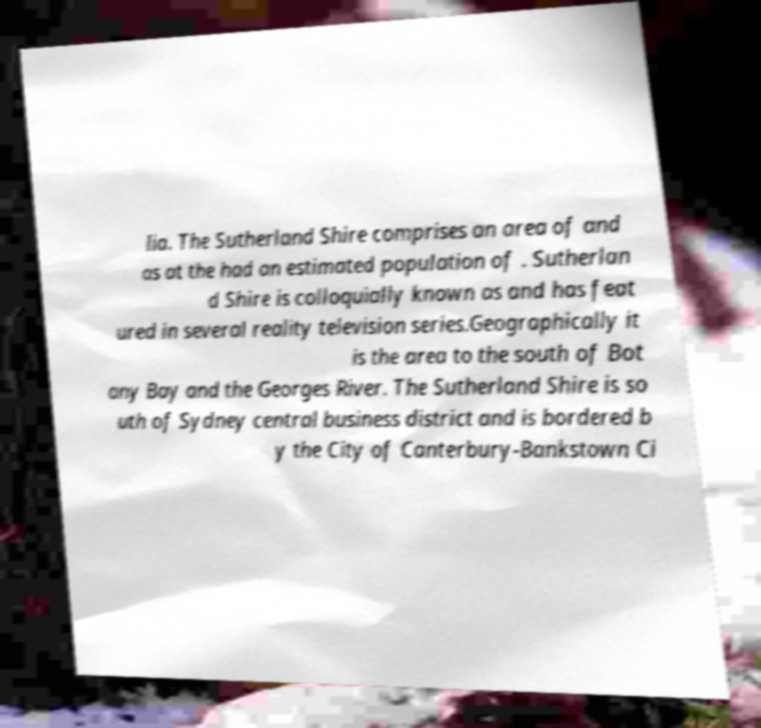There's text embedded in this image that I need extracted. Can you transcribe it verbatim? lia. The Sutherland Shire comprises an area of and as at the had an estimated population of . Sutherlan d Shire is colloquially known as and has feat ured in several reality television series.Geographically it is the area to the south of Bot any Bay and the Georges River. The Sutherland Shire is so uth of Sydney central business district and is bordered b y the City of Canterbury-Bankstown Ci 